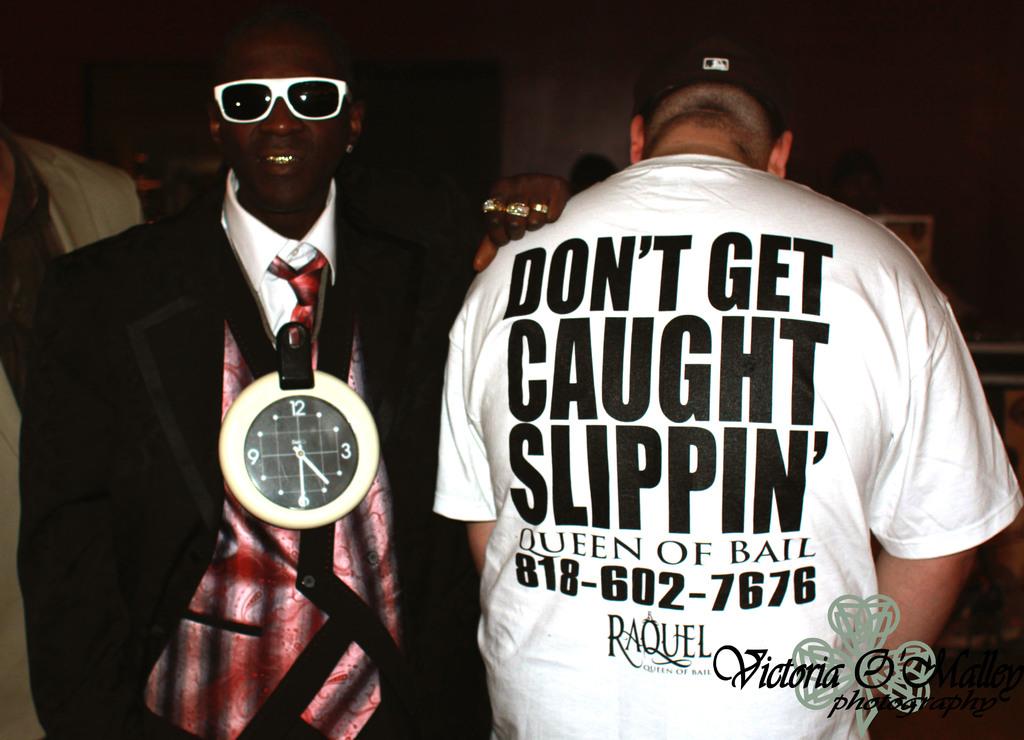What is the phone number?
Provide a succinct answer. 818-602-7676. What does the shirt say not to get caught doing?
Keep it short and to the point. Slippin'. 